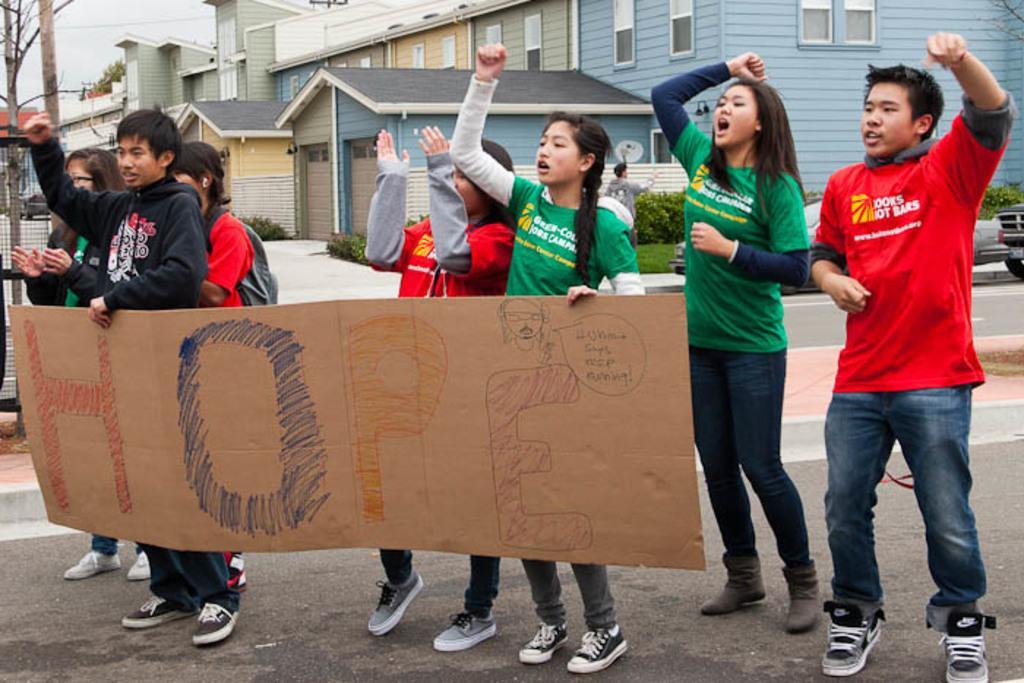Describe this image in one or two sentences. There are persons in different color dresses, some of them are holding a placard on a road. In the background, there are plants and grass on the ground, there are buildings which are having roofs and glass windows and there is sky. 